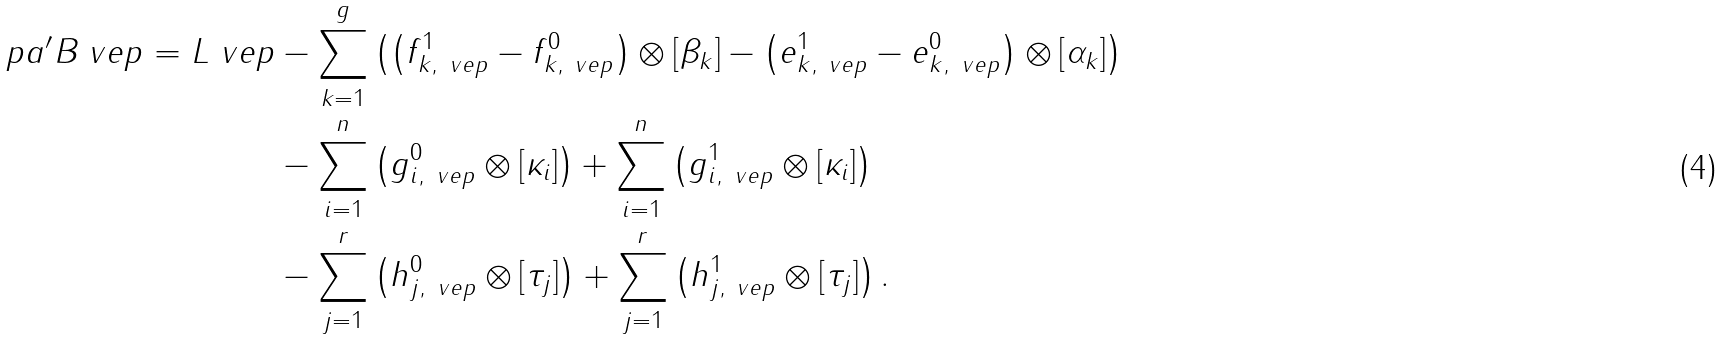Convert formula to latex. <formula><loc_0><loc_0><loc_500><loc_500>\ p a ^ { \prime } B _ { \ } v e p = L _ { \ } v e p & - \sum _ { k = 1 } ^ { g } \left ( \left ( f _ { k , \ v e p } ^ { 1 } - f _ { k , \ v e p } ^ { 0 } \right ) \otimes [ \beta _ { k } ] - \left ( e _ { k , \ v e p } ^ { 1 } - e _ { k , \ v e p } ^ { 0 } \right ) \otimes [ \alpha _ { k } ] \right ) \\ & - \sum _ { i = 1 } ^ { n } \left ( g _ { i , \ v e p } ^ { 0 } \otimes [ \kappa _ { i } ] \right ) + \sum _ { i = 1 } ^ { n } \left ( g _ { i , \ v e p } ^ { 1 } \otimes [ \kappa _ { i } ] \right ) \\ & - \sum _ { j = 1 } ^ { r } \left ( h _ { j , \ v e p } ^ { 0 } \otimes [ \tau _ { j } ] \right ) + \sum _ { j = 1 } ^ { r } \left ( h _ { j , \ v e p } ^ { 1 } \otimes [ \tau _ { j } ] \right ) .</formula> 